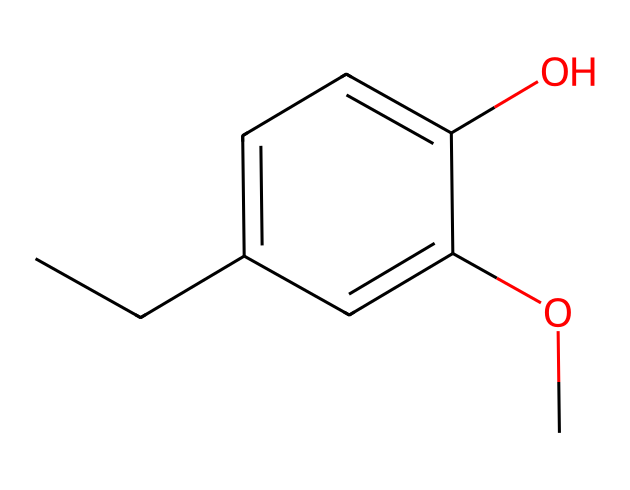What is the name of the chemical represented by the SMILES? The SMILES representation corresponds to a chemical structure that can be analyzed, revealing that it has a hydroxyl (-OH) group and is derived from eugenol.
Answer: eugenol How many carbon atoms are present in eugenol? By inspecting the SMILES representation, we can count the number of carbon (C) atoms, which appear in various parts of the structure: there are 10 carbon atoms total.
Answer: 10 How many hydroxyl (-OH) groups are in the structure? The presence of the hydroxyl group is indicated in the structure. In this case, there is only one hydroxyl group represented in the chemical.
Answer: 1 Is eugenol classified as a phenol? Phenols are characterized by the presence of a hydroxyl group attached to an aromatic ring. Since eugenol has this structure, it is classified as a phenol.
Answer: yes What functional groups are present in eugenol? Analyzing the structure reveals the presence of a hydroxyl group (-OH) and a methoxy group (-OCH3), identifying these as the functional groups present.
Answer: hydroxyl and methoxy 